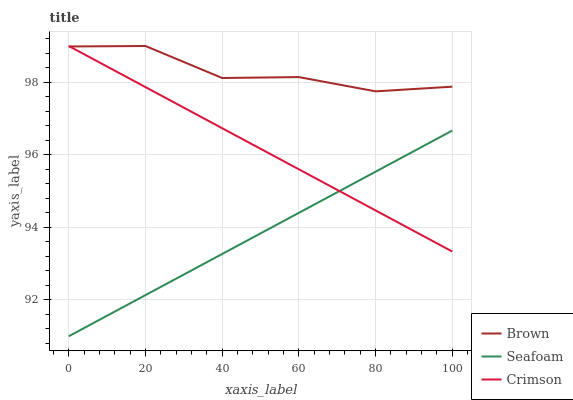Does Seafoam have the minimum area under the curve?
Answer yes or no. Yes. Does Brown have the maximum area under the curve?
Answer yes or no. Yes. Does Brown have the minimum area under the curve?
Answer yes or no. No. Does Seafoam have the maximum area under the curve?
Answer yes or no. No. Is Crimson the smoothest?
Answer yes or no. Yes. Is Brown the roughest?
Answer yes or no. Yes. Is Seafoam the smoothest?
Answer yes or no. No. Is Seafoam the roughest?
Answer yes or no. No. Does Seafoam have the lowest value?
Answer yes or no. Yes. Does Brown have the lowest value?
Answer yes or no. No. Does Brown have the highest value?
Answer yes or no. Yes. Does Seafoam have the highest value?
Answer yes or no. No. Is Seafoam less than Brown?
Answer yes or no. Yes. Is Brown greater than Seafoam?
Answer yes or no. Yes. Does Brown intersect Crimson?
Answer yes or no. Yes. Is Brown less than Crimson?
Answer yes or no. No. Is Brown greater than Crimson?
Answer yes or no. No. Does Seafoam intersect Brown?
Answer yes or no. No. 